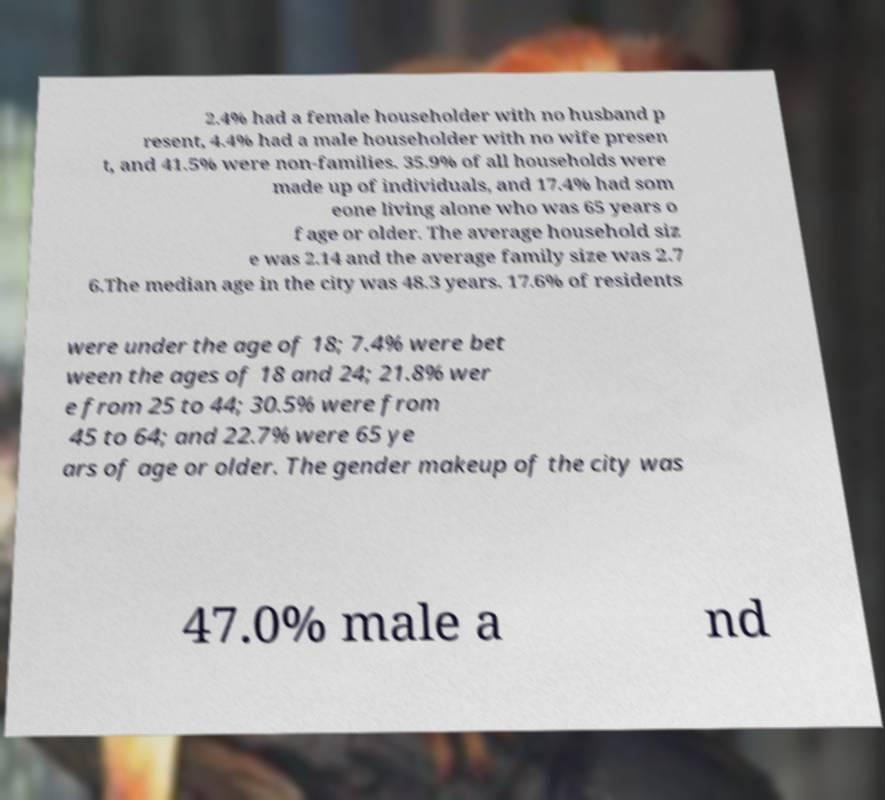Could you extract and type out the text from this image? 2.4% had a female householder with no husband p resent, 4.4% had a male householder with no wife presen t, and 41.5% were non-families. 35.9% of all households were made up of individuals, and 17.4% had som eone living alone who was 65 years o f age or older. The average household siz e was 2.14 and the average family size was 2.7 6.The median age in the city was 48.3 years. 17.6% of residents were under the age of 18; 7.4% were bet ween the ages of 18 and 24; 21.8% wer e from 25 to 44; 30.5% were from 45 to 64; and 22.7% were 65 ye ars of age or older. The gender makeup of the city was 47.0% male a nd 